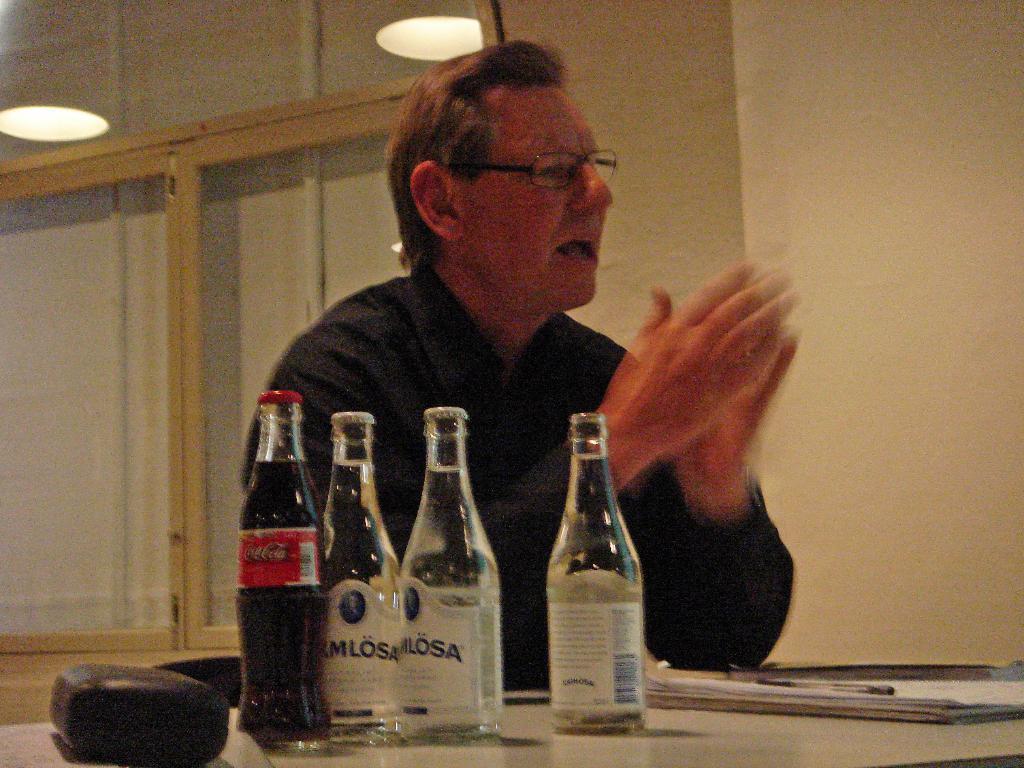In one or two sentences, can you explain what this image depicts? A person is sitting on the chair at the table. On the table there are 4 bottles,book,pen and a box. In the background there is a wall,windows and reflection of light. 